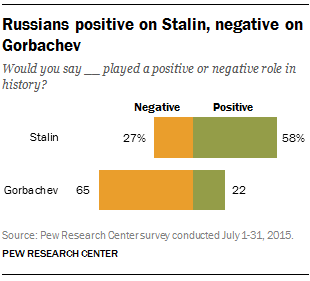Draw attention to some important aspects in this diagram. The graph displays two colors. Gorbachev's highest percentage was 43%. 